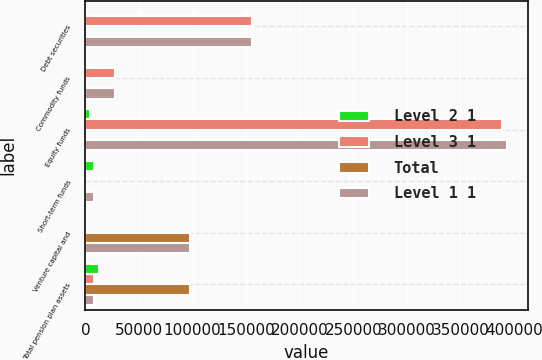Convert chart. <chart><loc_0><loc_0><loc_500><loc_500><stacked_bar_chart><ecel><fcel>Debt securities<fcel>Commodity funds<fcel>Equity funds<fcel>Short-term funds<fcel>Venture capital and<fcel>Total pension plan assets<nl><fcel>Level 2 1<fcel>0<fcel>0<fcel>4503<fcel>8298<fcel>0<fcel>12801<nl><fcel>Level 3 1<fcel>155874<fcel>27906<fcel>388499<fcel>0<fcel>0<fcel>8298<nl><fcel>Total<fcel>0<fcel>0<fcel>0<fcel>0<fcel>98011<fcel>98011<nl><fcel>Level 1 1<fcel>155874<fcel>27906<fcel>393002<fcel>8298<fcel>98011<fcel>8298<nl></chart> 